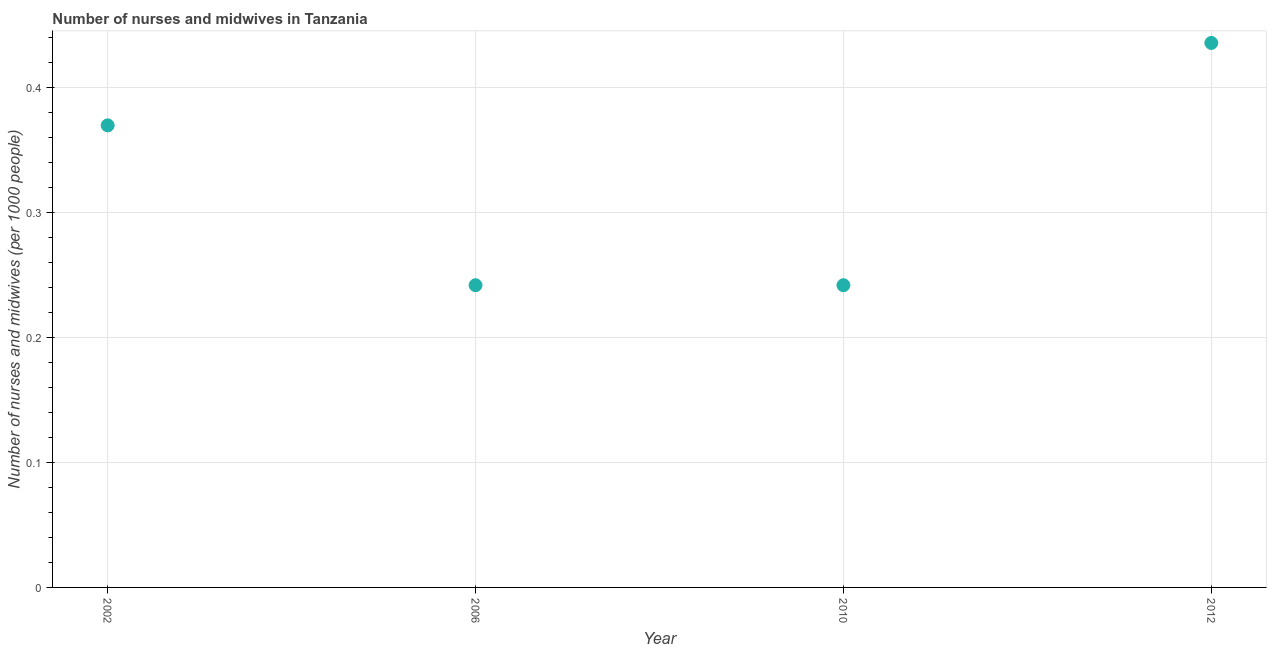What is the number of nurses and midwives in 2012?
Keep it short and to the point. 0.44. Across all years, what is the maximum number of nurses and midwives?
Keep it short and to the point. 0.44. Across all years, what is the minimum number of nurses and midwives?
Your response must be concise. 0.24. In which year was the number of nurses and midwives maximum?
Ensure brevity in your answer.  2012. What is the sum of the number of nurses and midwives?
Your response must be concise. 1.29. What is the difference between the number of nurses and midwives in 2002 and 2010?
Offer a very short reply. 0.13. What is the average number of nurses and midwives per year?
Ensure brevity in your answer.  0.32. What is the median number of nurses and midwives?
Make the answer very short. 0.31. What is the ratio of the number of nurses and midwives in 2002 to that in 2010?
Your answer should be very brief. 1.53. Is the number of nurses and midwives in 2002 less than that in 2010?
Your answer should be very brief. No. What is the difference between the highest and the second highest number of nurses and midwives?
Offer a very short reply. 0.07. What is the difference between the highest and the lowest number of nurses and midwives?
Give a very brief answer. 0.19. In how many years, is the number of nurses and midwives greater than the average number of nurses and midwives taken over all years?
Provide a short and direct response. 2. What is the difference between two consecutive major ticks on the Y-axis?
Offer a terse response. 0.1. Are the values on the major ticks of Y-axis written in scientific E-notation?
Make the answer very short. No. What is the title of the graph?
Make the answer very short. Number of nurses and midwives in Tanzania. What is the label or title of the Y-axis?
Ensure brevity in your answer.  Number of nurses and midwives (per 1000 people). What is the Number of nurses and midwives (per 1000 people) in 2002?
Your answer should be very brief. 0.37. What is the Number of nurses and midwives (per 1000 people) in 2006?
Offer a terse response. 0.24. What is the Number of nurses and midwives (per 1000 people) in 2010?
Your answer should be compact. 0.24. What is the Number of nurses and midwives (per 1000 people) in 2012?
Give a very brief answer. 0.44. What is the difference between the Number of nurses and midwives (per 1000 people) in 2002 and 2006?
Your answer should be compact. 0.13. What is the difference between the Number of nurses and midwives (per 1000 people) in 2002 and 2010?
Offer a very short reply. 0.13. What is the difference between the Number of nurses and midwives (per 1000 people) in 2002 and 2012?
Ensure brevity in your answer.  -0.07. What is the difference between the Number of nurses and midwives (per 1000 people) in 2006 and 2010?
Your response must be concise. 0. What is the difference between the Number of nurses and midwives (per 1000 people) in 2006 and 2012?
Make the answer very short. -0.19. What is the difference between the Number of nurses and midwives (per 1000 people) in 2010 and 2012?
Ensure brevity in your answer.  -0.19. What is the ratio of the Number of nurses and midwives (per 1000 people) in 2002 to that in 2006?
Provide a short and direct response. 1.53. What is the ratio of the Number of nurses and midwives (per 1000 people) in 2002 to that in 2010?
Provide a succinct answer. 1.53. What is the ratio of the Number of nurses and midwives (per 1000 people) in 2002 to that in 2012?
Make the answer very short. 0.85. What is the ratio of the Number of nurses and midwives (per 1000 people) in 2006 to that in 2012?
Keep it short and to the point. 0.56. What is the ratio of the Number of nurses and midwives (per 1000 people) in 2010 to that in 2012?
Make the answer very short. 0.56. 